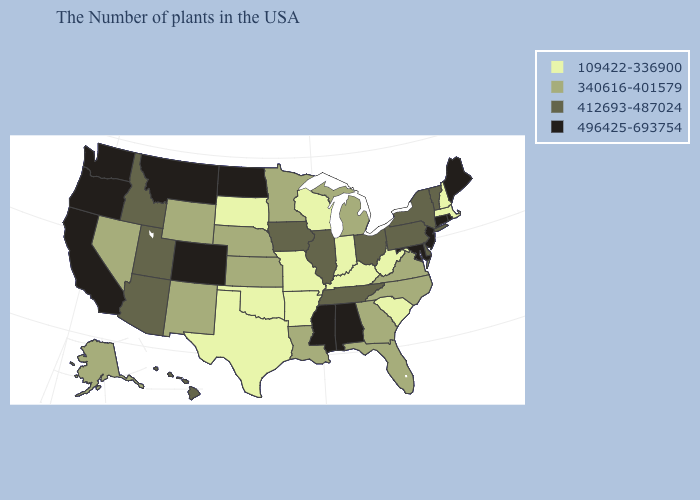What is the lowest value in states that border Indiana?
Concise answer only. 109422-336900. What is the value of California?
Concise answer only. 496425-693754. Name the states that have a value in the range 340616-401579?
Give a very brief answer. Virginia, North Carolina, Florida, Georgia, Michigan, Louisiana, Minnesota, Kansas, Nebraska, Wyoming, New Mexico, Nevada, Alaska. What is the value of North Dakota?
Concise answer only. 496425-693754. Does Wyoming have the lowest value in the West?
Keep it brief. Yes. Name the states that have a value in the range 109422-336900?
Quick response, please. Massachusetts, New Hampshire, South Carolina, West Virginia, Kentucky, Indiana, Wisconsin, Missouri, Arkansas, Oklahoma, Texas, South Dakota. What is the highest value in the USA?
Answer briefly. 496425-693754. What is the lowest value in the MidWest?
Quick response, please. 109422-336900. Does North Carolina have the lowest value in the South?
Quick response, please. No. What is the lowest value in the Northeast?
Write a very short answer. 109422-336900. What is the highest value in states that border Montana?
Be succinct. 496425-693754. How many symbols are there in the legend?
Answer briefly. 4. How many symbols are there in the legend?
Write a very short answer. 4. How many symbols are there in the legend?
Concise answer only. 4. Which states have the lowest value in the West?
Be succinct. Wyoming, New Mexico, Nevada, Alaska. 